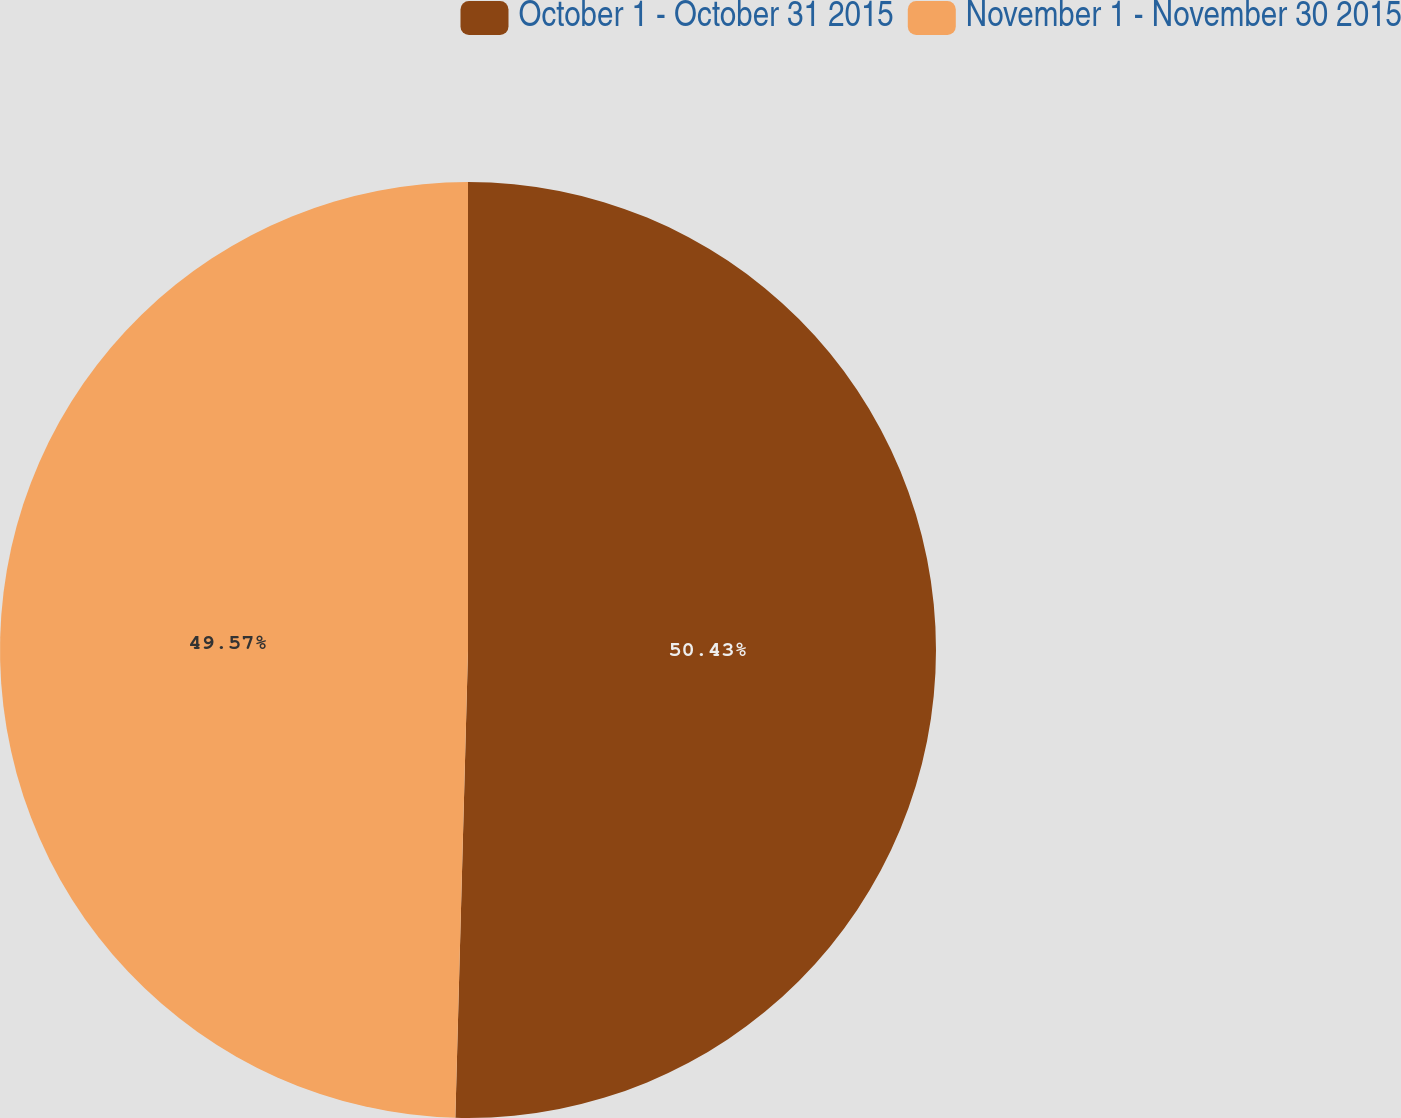Convert chart. <chart><loc_0><loc_0><loc_500><loc_500><pie_chart><fcel>October 1 - October 31 2015<fcel>November 1 - November 30 2015<nl><fcel>50.43%<fcel>49.57%<nl></chart> 